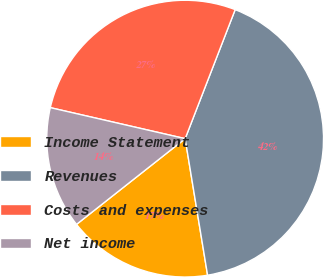Convert chart. <chart><loc_0><loc_0><loc_500><loc_500><pie_chart><fcel>Income Statement<fcel>Revenues<fcel>Costs and expenses<fcel>Net income<nl><fcel>16.96%<fcel>41.52%<fcel>27.29%<fcel>14.23%<nl></chart> 